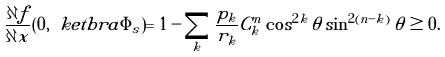Convert formula to latex. <formula><loc_0><loc_0><loc_500><loc_500>\frac { \partial f } { \partial x } ( 0 , \ k e t b r a { \Phi _ { s } } ) = 1 - \sum _ { k } \frac { p _ { k } } { r _ { k } } C ^ { n } _ { k } \cos ^ { 2 k } \theta \sin ^ { 2 ( n - k ) } \theta \geq 0 .</formula> 